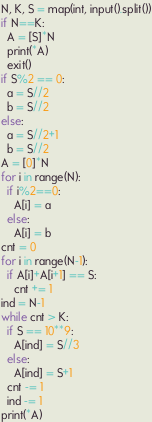<code> <loc_0><loc_0><loc_500><loc_500><_Python_>N, K, S = map(int, input().split())
if N==K:
  A = [S]*N
  print(*A)
  exit()
if S%2 == 0:
  a = S//2
  b = S//2
else:
  a = S//2+1
  b = S//2
A = [0]*N
for i in range(N):
  if i%2==0:
    A[i] = a
  else:
    A[i] = b
cnt = 0
for i in range(N-1):
  if A[i]+A[i+1] == S:
    cnt += 1
ind = N-1
while cnt > K:
  if S == 10**9:
    A[ind] = S//3
  else:
    A[ind] = S+1
  cnt -= 1
  ind -= 1
print(*A)</code> 